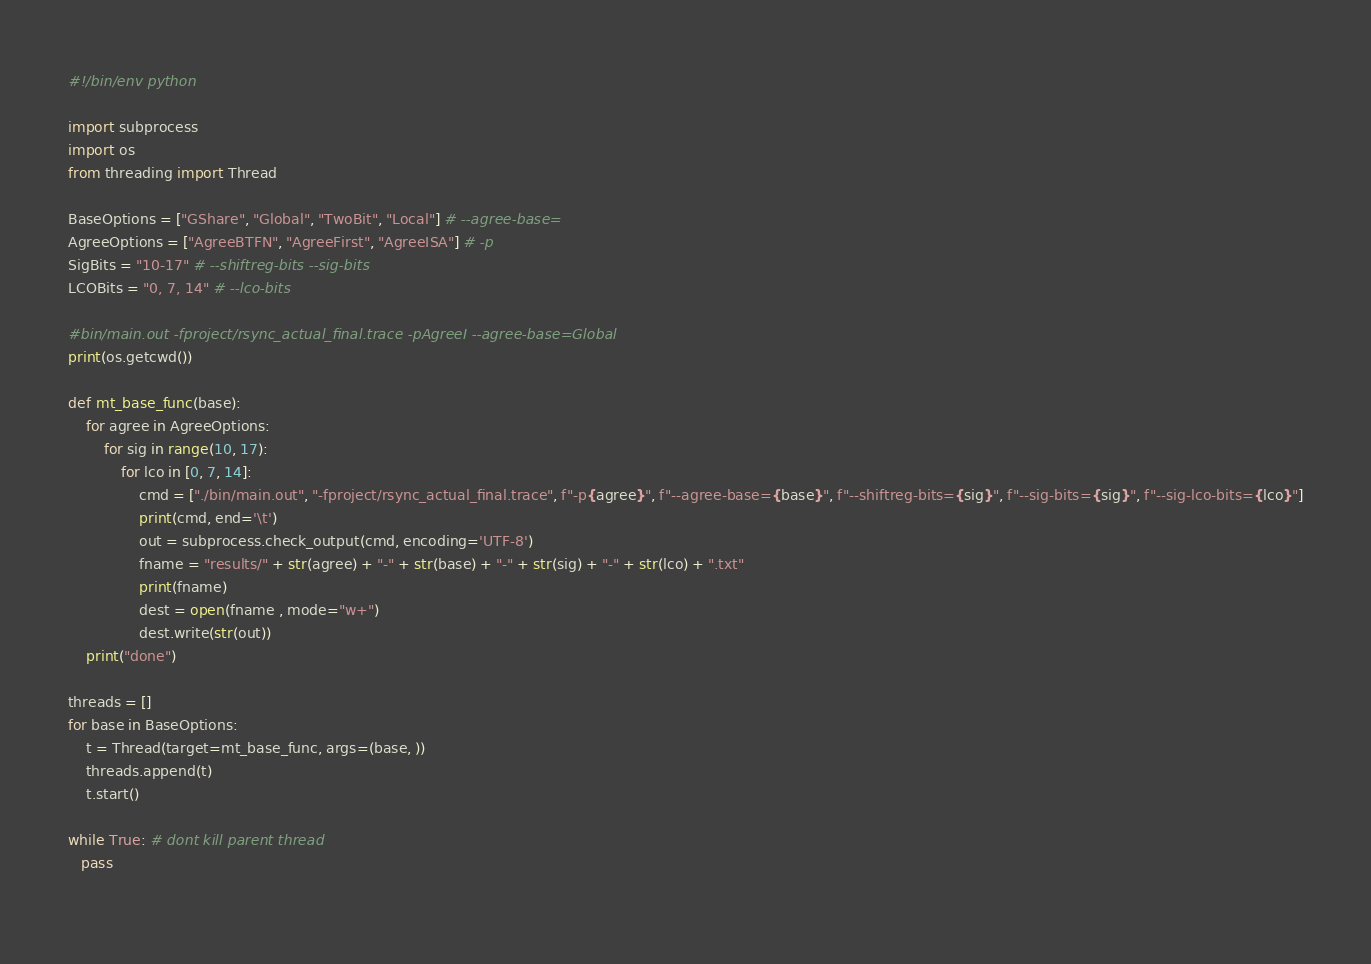<code> <loc_0><loc_0><loc_500><loc_500><_Python_>#!/bin/env python

import subprocess
import os
from threading import Thread

BaseOptions = ["GShare", "Global", "TwoBit", "Local"] # --agree-base=
AgreeOptions = ["AgreeBTFN", "AgreeFirst", "AgreeISA"] # -p
SigBits = "10-17" # --shiftreg-bits --sig-bits
LCOBits = "0, 7, 14" # --lco-bits

#bin/main.out -fproject/rsync_actual_final.trace -pAgreeI --agree-base=Global
print(os.getcwd())

def mt_base_func(base):
	for agree in AgreeOptions:
		for sig in range(10, 17):
			for lco in [0, 7, 14]:
				cmd = ["./bin/main.out", "-fproject/rsync_actual_final.trace", f"-p{agree}", f"--agree-base={base}", f"--shiftreg-bits={sig}", f"--sig-bits={sig}", f"--sig-lco-bits={lco}"]
				print(cmd, end='\t')
				out = subprocess.check_output(cmd, encoding='UTF-8')
				fname = "results/" + str(agree) + "-" + str(base) + "-" + str(sig) + "-" + str(lco) + ".txt"
				print(fname)
				dest = open(fname , mode="w+")
				dest.write(str(out))
	print("done")

threads = []
for base in BaseOptions:
	t = Thread(target=mt_base_func, args=(base, ))
	threads.append(t)
	t.start()

while True: # dont kill parent thread
   pass
   </code> 